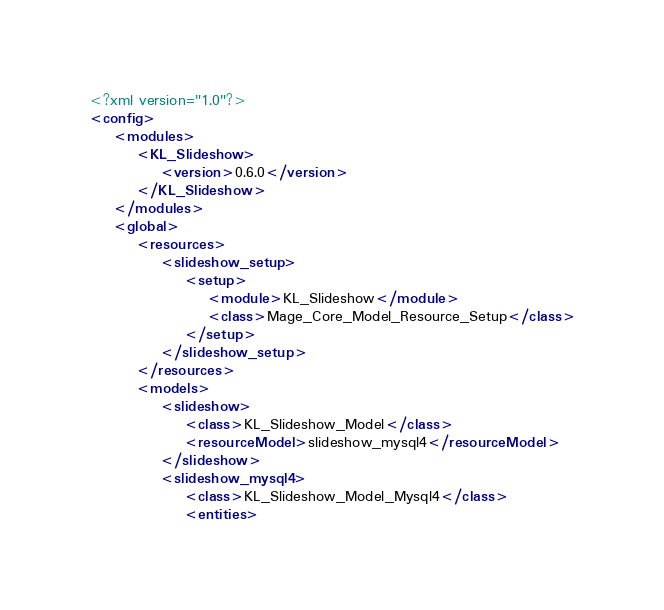Convert code to text. <code><loc_0><loc_0><loc_500><loc_500><_XML_><?xml version="1.0"?>
<config>
    <modules>
        <KL_Slideshow>
            <version>0.6.0</version>
        </KL_Slideshow>
    </modules>
    <global>
        <resources>
            <slideshow_setup>
                <setup>
                    <module>KL_Slideshow</module>
                    <class>Mage_Core_Model_Resource_Setup</class>
                </setup>
            </slideshow_setup>
        </resources>
        <models>
            <slideshow>
                <class>KL_Slideshow_Model</class>
                <resourceModel>slideshow_mysql4</resourceModel>
            </slideshow>
            <slideshow_mysql4>
                <class>KL_Slideshow_Model_Mysql4</class>
                <entities></code> 